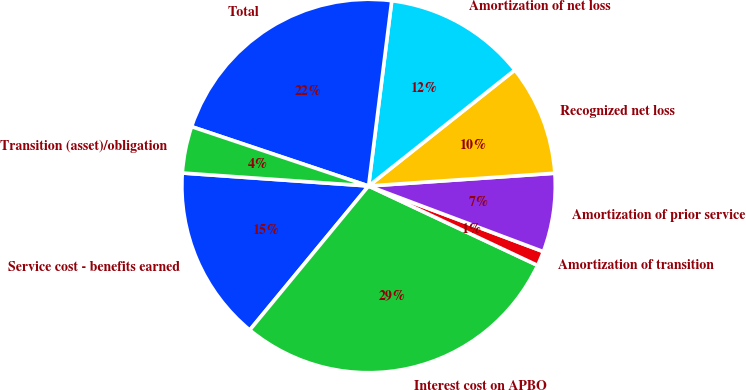Convert chart to OTSL. <chart><loc_0><loc_0><loc_500><loc_500><pie_chart><fcel>Service cost - benefits earned<fcel>Interest cost on APBO<fcel>Amortization of transition<fcel>Amortization of prior service<fcel>Recognized net loss<fcel>Amortization of net loss<fcel>Total<fcel>Transition (asset)/obligation<nl><fcel>15.13%<fcel>28.99%<fcel>1.27%<fcel>6.81%<fcel>9.58%<fcel>12.35%<fcel>21.83%<fcel>4.04%<nl></chart> 